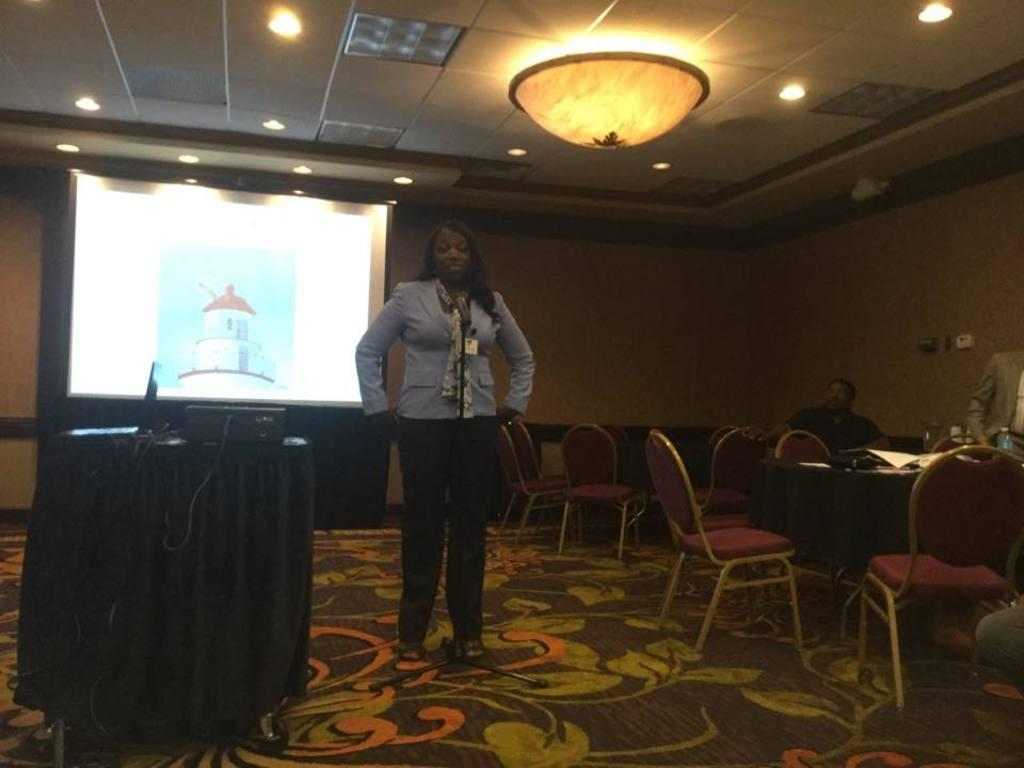What is the main subject of the image? There is a woman standing in the image. What can be seen behind the woman? There is a wall and a screen behind the woman. What musical instruments are visible in the image? There are drums on the left side of the image. What type of furniture is on the right side of the image? There are tables and chairs on the right side of the image. How many babies are crawling on the floor in the image? There are no babies present in the image. Is there a beggar asking for money in the image? There is no beggar present in the image. 